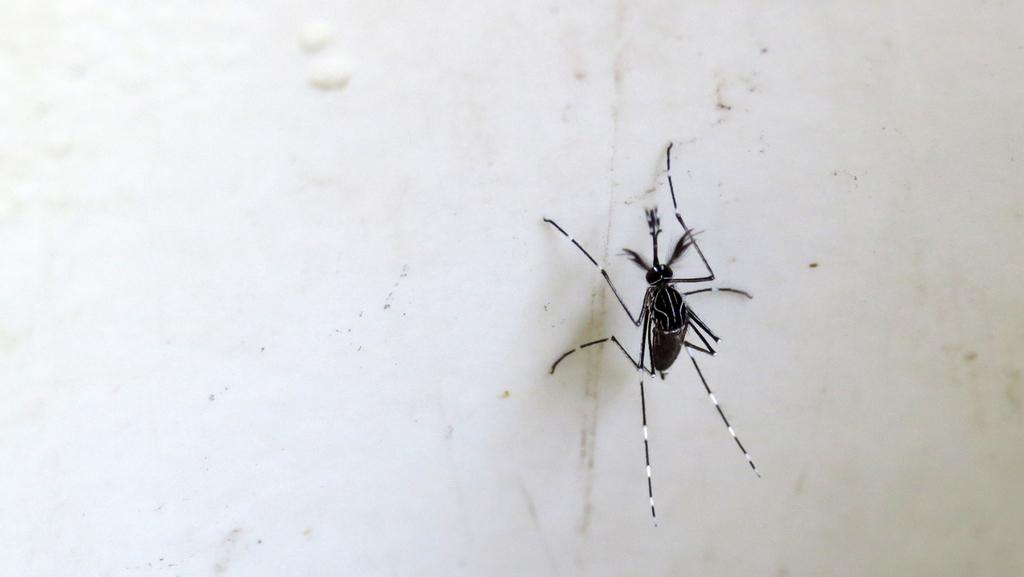What is present in the image? There is a mosquito in the image. Where is the mosquito located? The mosquito is on the wall. How many cakes are on the table in the image? There is no table or cakes present in the image; it only features a mosquito on the wall. 